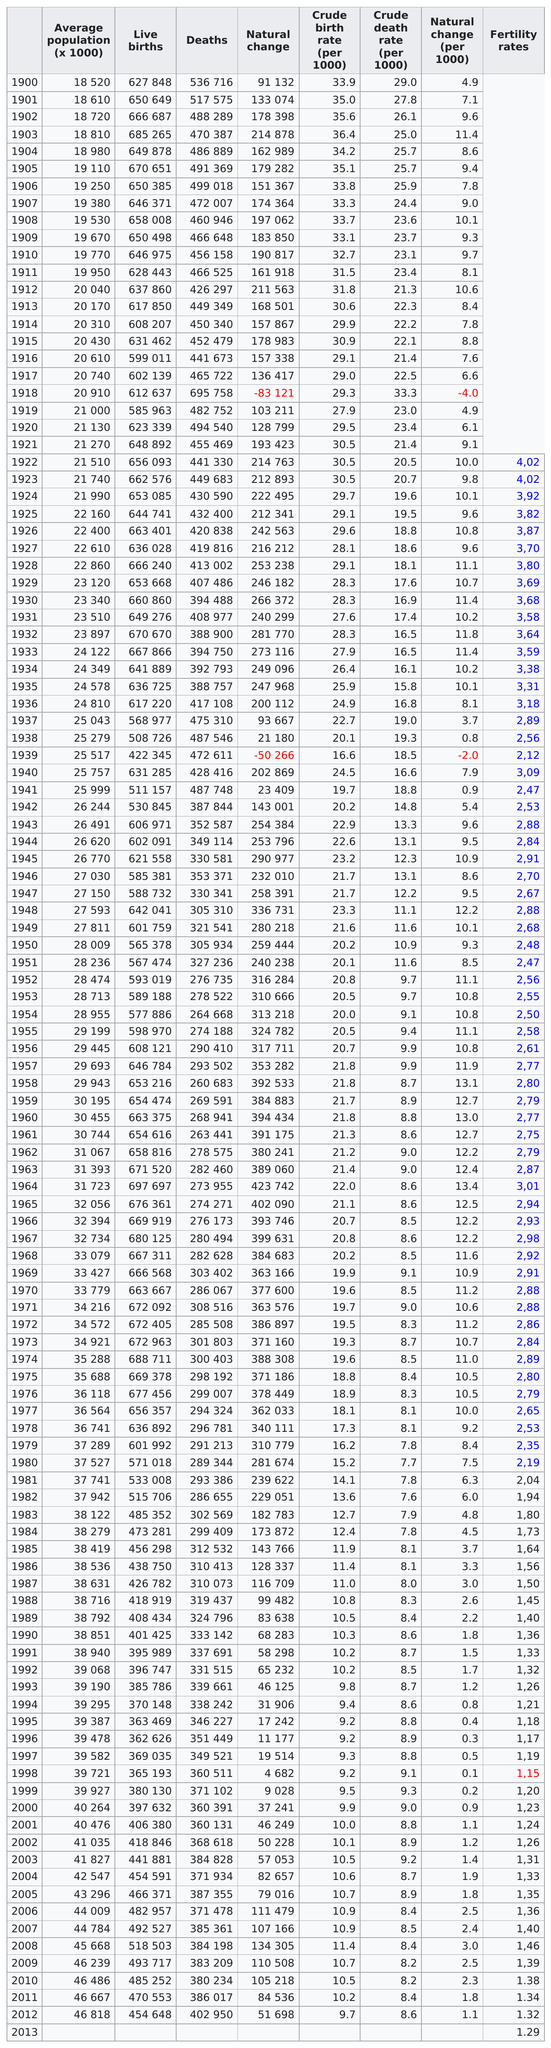Point out several critical features in this image. In 1964, Spain exhibited the highest number of live births compared to deaths. Between 1919 and 1933, the year with the highest natural change was 1932. In 1918, there was a significant decrease in the number of live births in Spain compared to the number of deaths, making it the year with the greatest decrease in Spain's live births over deaths. In 1928, the crude birth rate was 29.1 and the population was 22,860. 